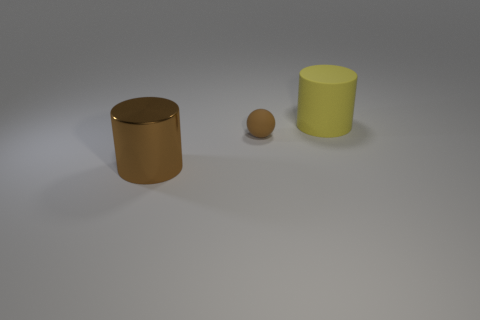Is there any other thing that is the same size as the sphere?
Keep it short and to the point. No. Do the rubber ball and the large shiny cylinder have the same color?
Make the answer very short. Yes. Are there any other things that are the same material as the large brown object?
Give a very brief answer. No. What is the yellow cylinder made of?
Give a very brief answer. Rubber. There is a large thing that is behind the large brown shiny cylinder that is in front of the tiny brown sphere; what is its shape?
Offer a terse response. Cylinder. How many other things are there of the same shape as the metal object?
Give a very brief answer. 1. Are there any big yellow rubber objects behind the yellow rubber object?
Your response must be concise. No. The metal thing has what color?
Provide a short and direct response. Brown. There is a tiny ball; is its color the same as the cylinder in front of the tiny brown object?
Offer a terse response. Yes. Are there any balls of the same size as the metal cylinder?
Provide a short and direct response. No. 